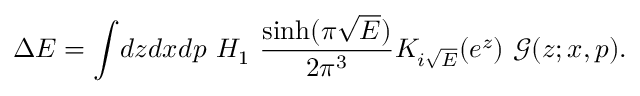<formula> <loc_0><loc_0><loc_500><loc_500>\Delta E = \int \, d z d x d p H _ { 1 } \frac { \sinh ( \pi \sqrt { E } ) } { 2 \pi ^ { 3 } } K _ { i \sqrt { E } } ( e ^ { z } ) \mathcal { G } ( z ; x , p ) .</formula> 